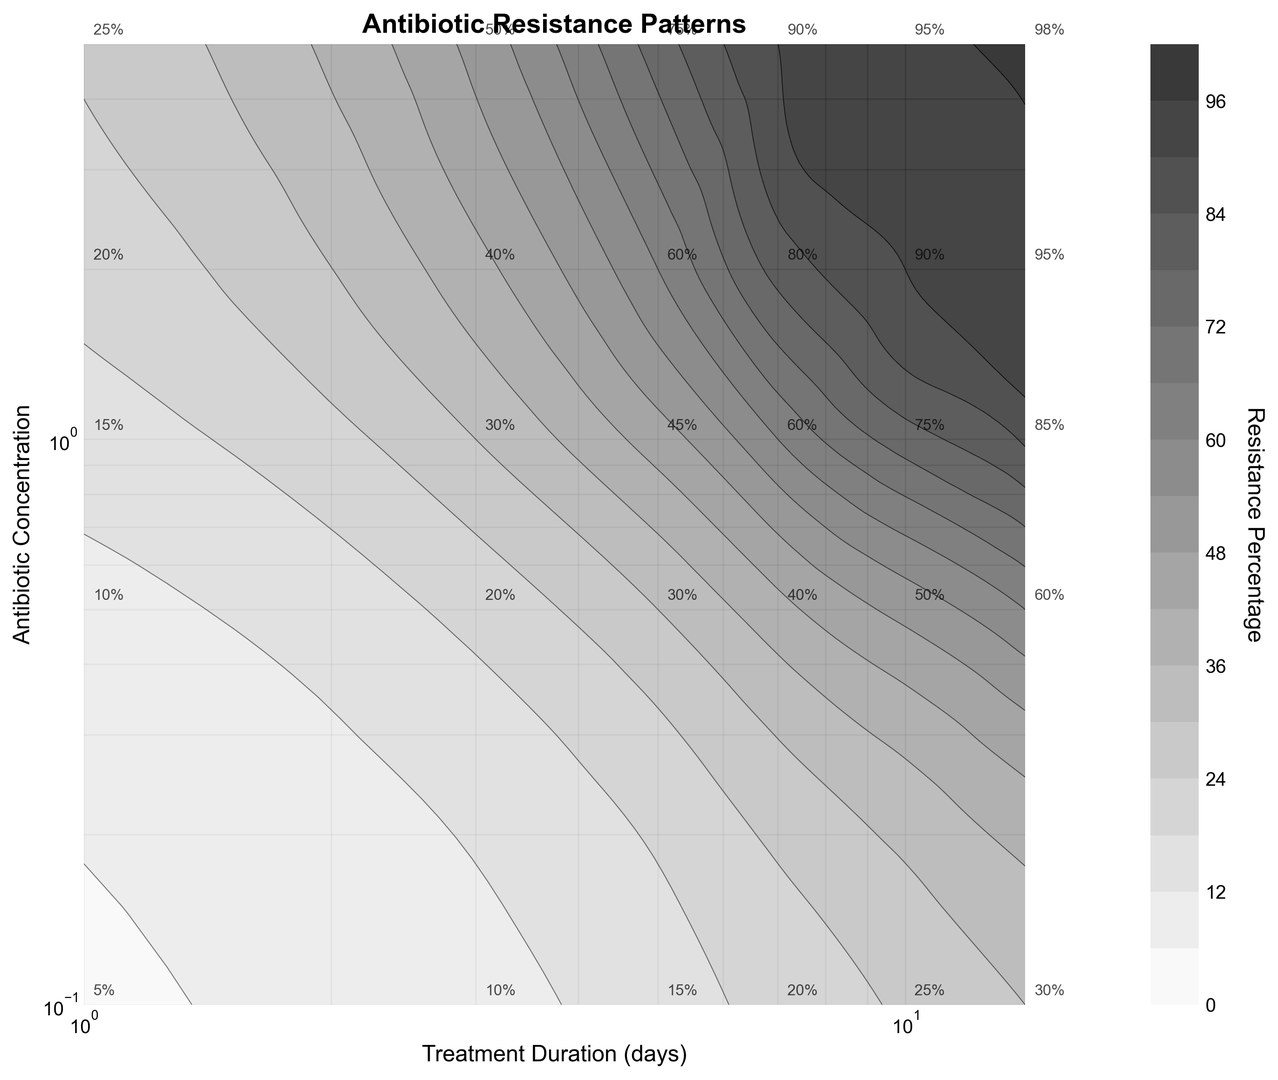What is the range of treatment duration where the resistance percentage exceeds 90%? To find the range of treatment duration where the resistance percentage exceeds 90%, look at the contour lines labeled 90%. These contours appear when the treatment duration is between approximately 10 days and 14 days at higher antibiotic concentrations.
Answer: 10-14 days Which treatment duration and antibiotic concentration pair results in the highest resistance percentage? To identify the pair resulting in the highest resistance percentage, find the data point with the maximum resistance percentage. According to the annotations on the figure, such pairs include a treatment duration of 14 days and an antibiotic concentration of 5.0.
Answer: (14 days, 5.0) How does the resistance percentage change as both treatment duration and antibiotic concentration increase? Observing the gradients in the contour lines, resistance percentage increases as both treatment duration and antibiotic concentration increase. This is seen by moving up-right on the plot, where contours show higher values.
Answer: Increases Between 1 and 10 days of treatment, which duration period exhibits a significant increase in resistance percentage for an antibiotic concentration of 0.1? Examine the contour lines for an antibiotic concentration of 0.1. The resistance percentage significantly increases from 5% to 25% between 1 and 10 days of treatment duration, showing a significant jump.
Answer: 10 days If the antibiotic concentration doubles from 2.0 to 4.0, how does this impact resistance percentage at the treatment duration of 7 days? To determine the impact, note the resistance percentages for the given antibiotic concentrations and treatment duration. At 7 days, resistance percentage at 2.0 is 80%, and 5.0 (close approximation for doubling) results in 90%, indicating an increase.
Answer: Increases What pattern can be observed about the rate of increase in resistance percentage between low and high antibiotic concentration for a given treatment duration? Observing the contour lines for different antibiotic concentrations at each treatment duration, the resistance percentage rises more sharply at lower concentrations (e.g., 0.1 to 1.0) and steadies at higher concentrations (e.g., 1.0 to 5.0) for each treatment duration.
Answer: Sharper increase at low concentrations Which resistance percentage shows the least variation across treatment durations for an antibiotic concentration of 1.0? Look at the horizontal contour line locations for an antibiotic concentration of 1.0. The resistance percentage contours nearest 75% seem to show the least variation, indicating a consistent trend for different treatment durations.
Answer: 75% How does the contour for 45% resistance change over different treatment durations? By tracing the 45% contour line, it starts at about 5 days for the lowest antibiotic concentration and shifts rightwards until it aligns with higher durations at increasing concentrations.
Answer: Shifts rightwards Compare the resistance percentage between treatment durations of 1 and 3 days at an antibiotic concentration of 0.5. Refer to respective contours and annotations showing at 0.5 concentration, 1 day is associated with 10% resistance, while 3 days is associated with 20%.
Answer: Higher at 3 days 